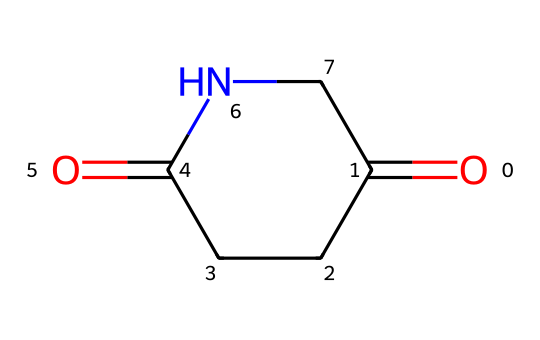What is the name of this chemical? The SMILES representation indicates the structure of a cyclic imide formed by connecting a five-membered ring containing one nitrogen atom and two carbonyl groups. This specific structure is known as glutarimide.
Answer: glutarimide How many carbon atoms are present in glutarimide? The chemical structure given has a total of four carbon atoms in the ring and two carbonyl groups, which can be counted from the SMILES representation.
Answer: four What type of functional groups are present in glutarimide? The key features of glutarimide include the cyclic structure with imide and carbonyl functional groups. Based on the SMILES, we can identify these two types of groups.
Answer: imide and carbonyl How many rings does glutarimide have? The SMILES structure reveals that the compound has a single cyclic structure formed by a five-membered ring system.
Answer: one What is the hybridization of the nitrogen atom in glutarimide? The nitrogen in glutarimide is bonded to two carbon atoms and has one lone pair, which indicates a trigonal planar arrangement, typical of sp2 hybridization.
Answer: sp2 What is the degree of unsaturation in glutarimide? The degree of unsaturation can be calculated based on the number of rings and double bonds present. The presence of one ring and two carbonyls generally indicates a degree of unsaturation of three, as each double bond and ring contributes one.
Answer: three 